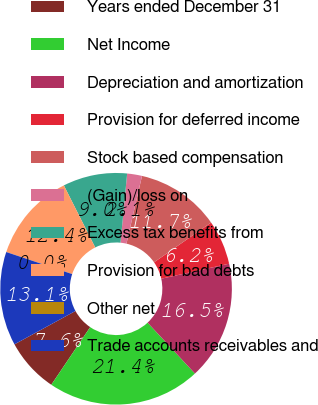<chart> <loc_0><loc_0><loc_500><loc_500><pie_chart><fcel>Years ended December 31<fcel>Net Income<fcel>Depreciation and amortization<fcel>Provision for deferred income<fcel>Stock based compensation<fcel>(Gain)/loss on<fcel>Excess tax benefits from<fcel>Provision for bad debts<fcel>Other net<fcel>Trade accounts receivables and<nl><fcel>7.59%<fcel>21.37%<fcel>16.55%<fcel>6.21%<fcel>11.72%<fcel>2.07%<fcel>8.97%<fcel>12.41%<fcel>0.01%<fcel>13.1%<nl></chart> 